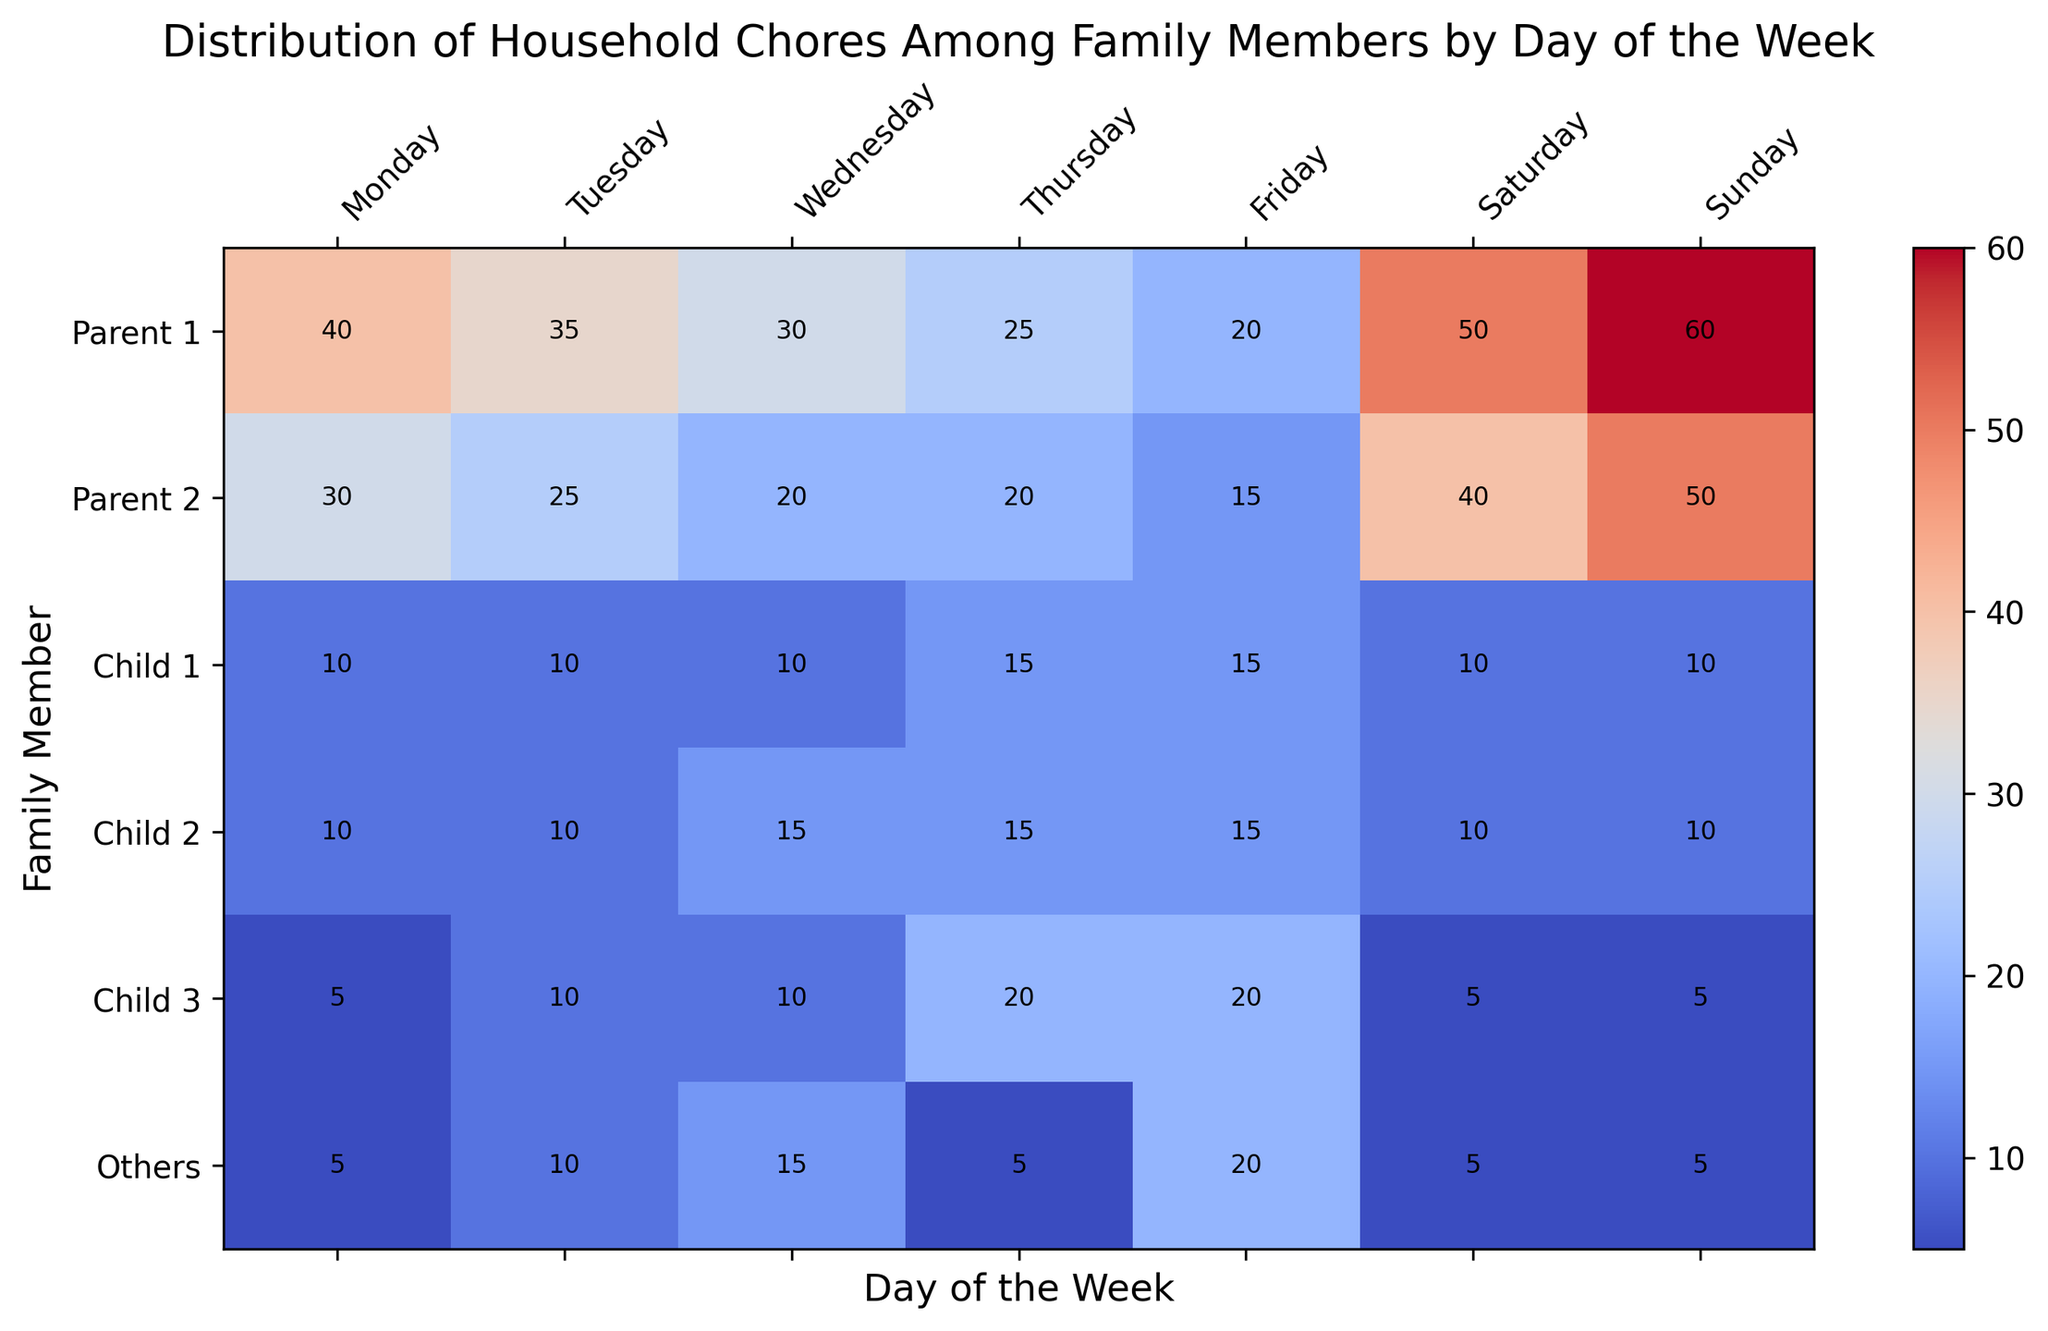What is the total number of household chores done by Parent 1 on weekends? On the heatmap, locate the cells for 'Parent 1' corresponding to 'Saturday' and 'Sunday'. Add the values: 50 (Saturday) + 60 (Sunday) = 110.
Answer: 110 Which family member does the least amount of household chores on Thursday? On the heatmap, check the cells in the 'Thursday' column and find the smallest value. 'Others' has 5 chores on Thursday, the lowest value in that column.
Answer: Others How many more chores does Parent 1 do on Monday than Parent 2? On the heatmap, find the 'Monday' values for 'Parent 1' and 'Parent 2'. Subtract Parent 2's value from Parent 1's value: 40 (Parent 1) - 30 (Parent 2) = 10.
Answer: 10 Which day has the most total household chores done by all family members? Sum the values in each column and compare. Find the highest sum:
- Monday = 40+30+10+10+5+5 = 100
- Tuesday = 35+25+10+10+10+10 = 100
- Wednesday = 30+20+10+15+10+15 = 100
- Thursday = 25+20+15+15+20+5 = 100
- Friday = 20+15+15+15+20+20 = 105
- Saturday = 50+40+10+10+5+5 = 120
- Sunday = 60+50+10+10+5+5 = 140
Sunday has the highest sum of 140.
Answer: Sunday Is there any day where Parent 1 and Parent 2 do an equal number of household chores? Compare the values for 'Parent 1' and 'Parent 2' for each day. On Friday, both Parent 1 and Parent 2 do 20 chores, which are equal.
Answer: Friday Which family member has the highest single-day chore count, and on which day? Check each value in the heatmap for the highest number. 'Parent 1' on 'Sunday' has the highest value of 60 chores.
Answer: Parent 1 on Sunday On which day do 'Child 1' and 'Child 2' both do exactly 15 chores? Check the 'Child 1' and 'Child 2' rows for overlapping 15 values. Both have 15 chores on Thursday and Friday.
Answer: Thursday and Friday What’s the difference in total chores between 'Parent 1' and 'Child 3' for the entire week? Sum the values for 'Parent 1' and 'Child 3' across all days:
- Parent 1: 40+35+30+25+20+50+60 = 260
- Child 3: 5+10+10+20+20+5+5 = 75
Then, subtract Child 3's total from Parent 1's total: 260 - 75 = 185.
Answer: 185 Which day shows the smallest workload variation among all family members? Calculate the range (max - min) for each day:
- Monday: 40 - 5 = 35
- Tuesday: 35 - 10 = 25
- Wednesday: 30 - 10 = 20
- Thursday: 25 - 5 = 20
- Friday: 20 - 15 = 5
- Saturday: 50 - 5 = 45
- Sunday: 60 - 5 = 55
The smallest range is 5, occurring on Friday.
Answer: Friday 